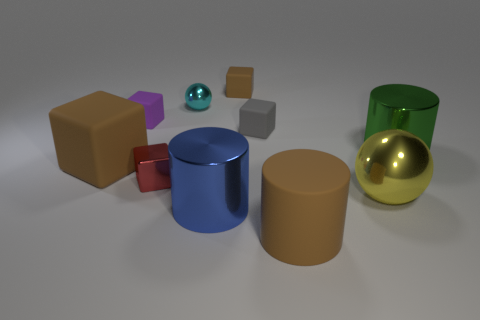Subtract all matte blocks. How many blocks are left? 1 Subtract all balls. How many objects are left? 8 Subtract all brown cylinders. How many cylinders are left? 2 Subtract 1 cylinders. How many cylinders are left? 2 Subtract all green cylinders. Subtract all gray balls. How many cylinders are left? 2 Subtract all blue cylinders. How many brown blocks are left? 2 Subtract all large brown metallic objects. Subtract all matte blocks. How many objects are left? 6 Add 4 large green metallic cylinders. How many large green metallic cylinders are left? 5 Add 4 green metallic cylinders. How many green metallic cylinders exist? 5 Subtract 0 green blocks. How many objects are left? 10 